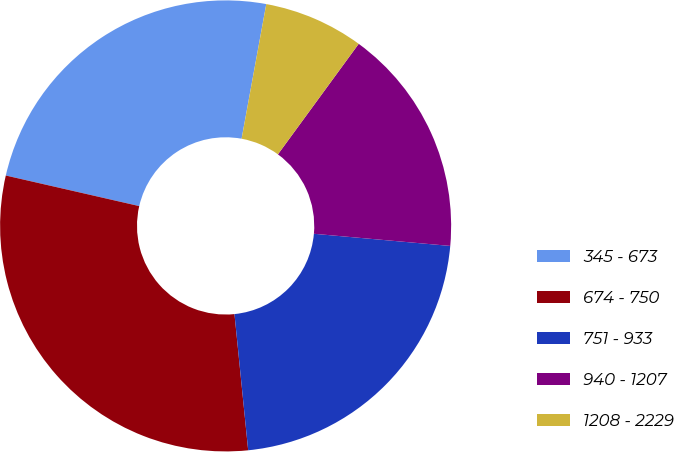Convert chart to OTSL. <chart><loc_0><loc_0><loc_500><loc_500><pie_chart><fcel>345 - 673<fcel>674 - 750<fcel>751 - 933<fcel>940 - 1207<fcel>1208 - 2229<nl><fcel>24.3%<fcel>30.18%<fcel>21.99%<fcel>16.37%<fcel>7.16%<nl></chart> 